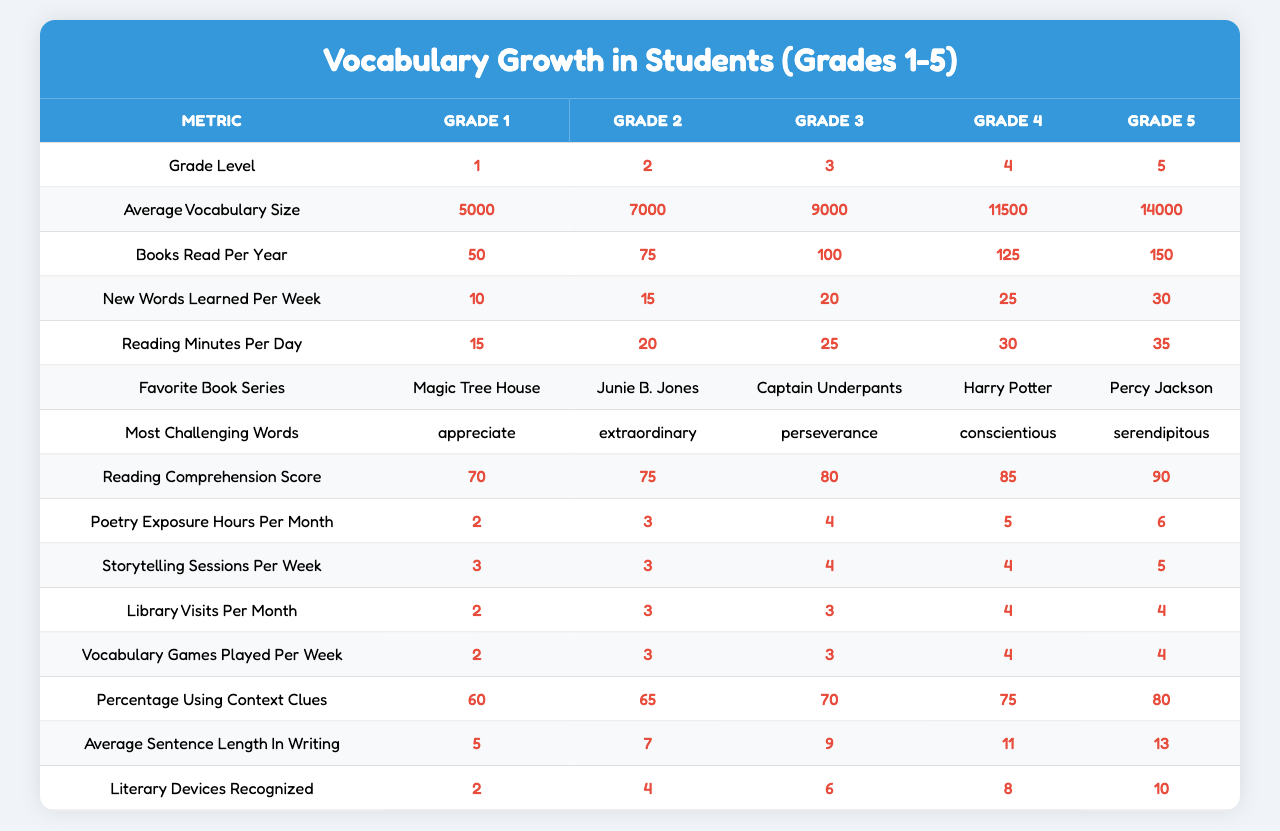What is the average vocabulary size for Grade 3 students? The table lists the average vocabulary sizes by grade level. For Grade 3, the average vocabulary size is listed as 9000.
Answer: 9000 How many new words do Grade 5 students learn per week? In the table, the column for new words learned per week shows that Grade 5 students learn 30 new words per week.
Answer: 30 Which grade level has the highest reading comprehension score? The reading comprehension scores for each grade level are provided. Grade 5 has the highest score listed at 90.
Answer: 90 What is the difference in average vocabulary size between Grade 1 and Grade 5? To find the difference, subtract the average vocabulary size of Grade 1 (5000) from that of Grade 5 (14000). The calculation is 14000 - 5000 = 9000.
Answer: 9000 Do Grade 4 students read more books per year than Grade 2 students? The books read per year for Grade 4 is 125, while Grade 2 reads 75 books per year. Since 125 is greater than 75, Grade 4 does read more.
Answer: Yes What is the median of the average sentence length in writing for all grades? To find the median, list the average sentence lengths: 5, 7, 9, 11, 13. There are 5 values, so the median is the middle value, which is 9.
Answer: 9 How many more hours of poetry exposure per month do Grade 5 students have compared to Grade 1 students? The table shows poetry exposure hours: Grade 5 has 6 hours and Grade 1 has 2 hours. The difference is calculated as 6 - 2 = 4 hours.
Answer: 4 What percentage of Grade 3 students use context clues while reading? According to the table, 70% of Grade 3 students use context clues, as listed in the relevant column.
Answer: 70% Which grade level's students recognized the most literary devices? Checking the "literary devices recognized" column, Grade 5 students recognized 10 literary devices, which is the highest.
Answer: 10 If a Grade 4 student reads for 30 minutes a day, how many minutes will they read in a month? For Grade 4, if a student reads 30 minutes per day, then over 30 days they will read 30 x 30 = 900 minutes in total.
Answer: 900 